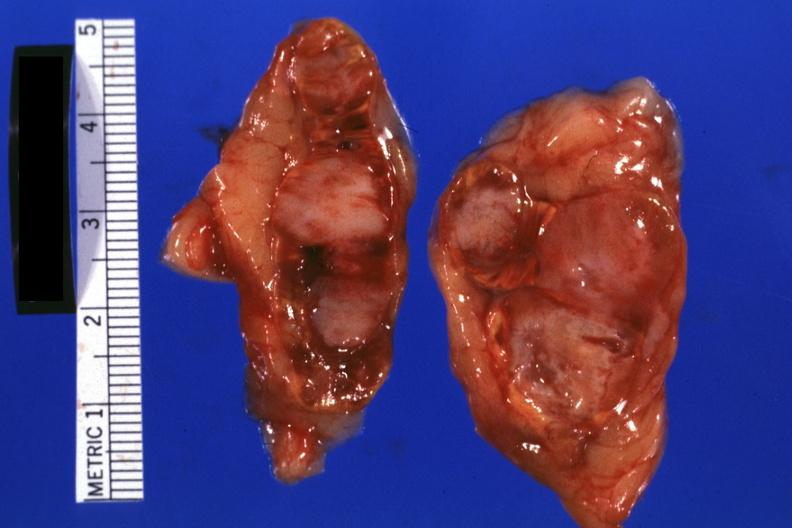what is present?
Answer the question using a single word or phrase. Metastatic carcinoma lung 